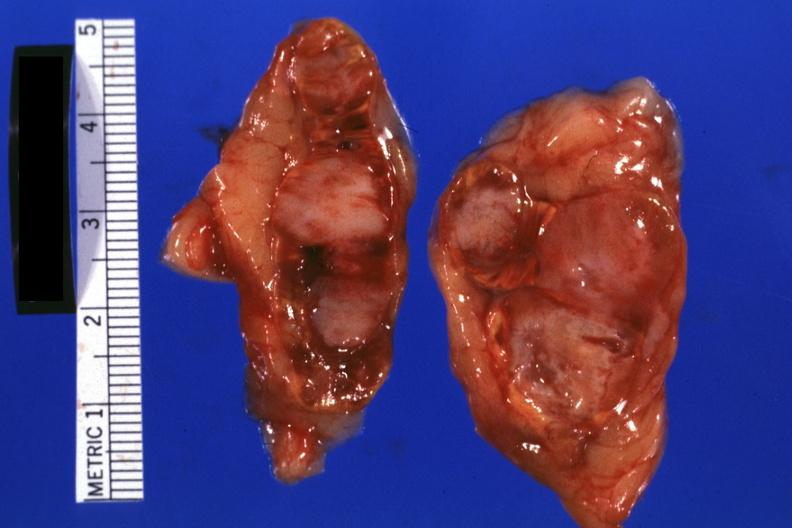what is present?
Answer the question using a single word or phrase. Metastatic carcinoma lung 